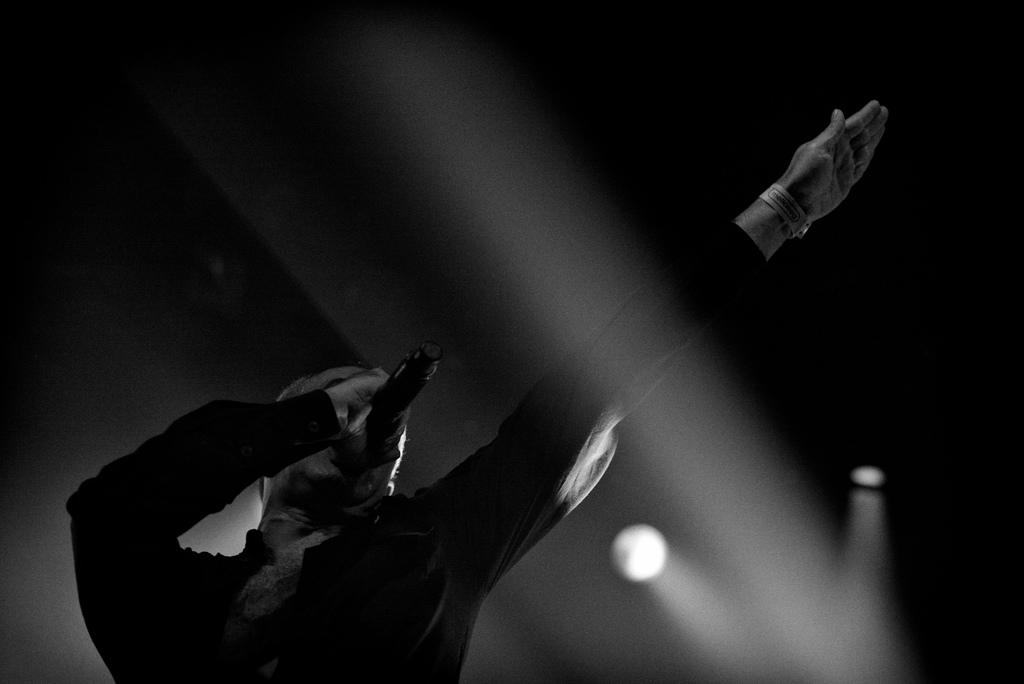What is the color scheme of the image? The image is black and white. Can you describe the person in the image? There is a person in the image. What is the person holding in the image? The person is holding a mic. What is the texture of the sun in the image? There is no sun present in the image, as it is black and white. What subject is the person teaching in the image? There is no indication of teaching or a specific subject in the image, as it only shows a person holding a mic. 